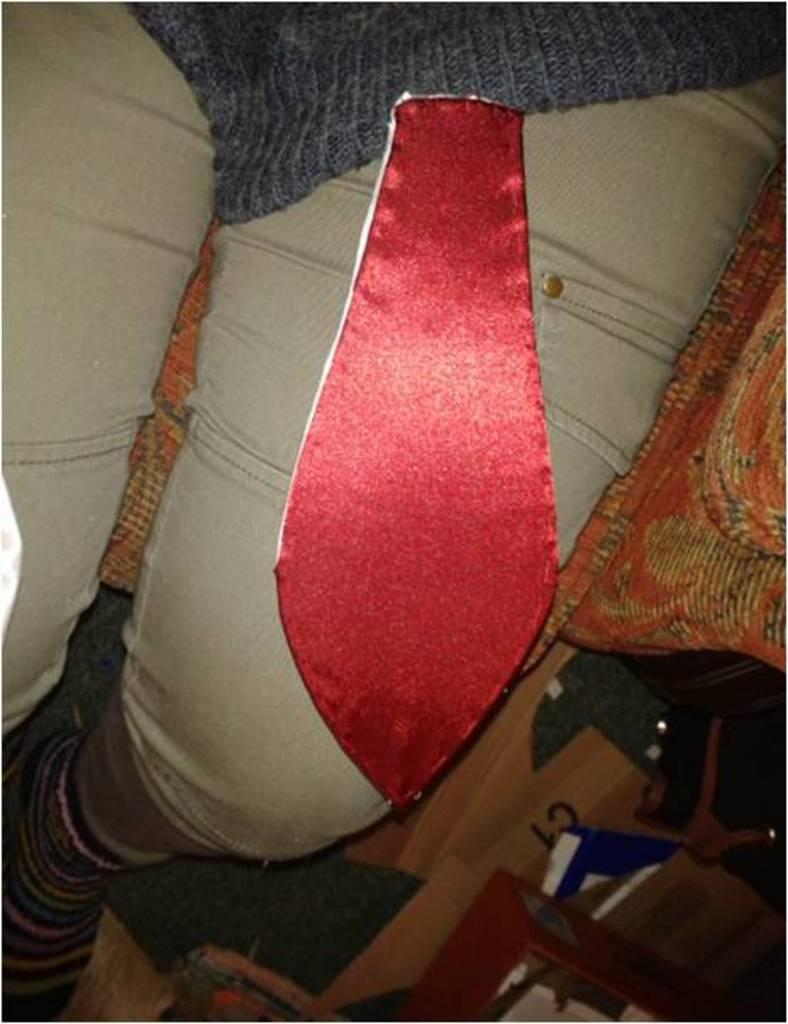What is the person in the image doing? There is a person sitting in the image. Can you describe the person's attire in the image? The person has a red tie on his lap. What type of cheese is the person eating in the image? There is no cheese present in the image, and the person is not eating anything. What game is the person playing in the image? There is no game being played in the image; the person is simply sitting. 